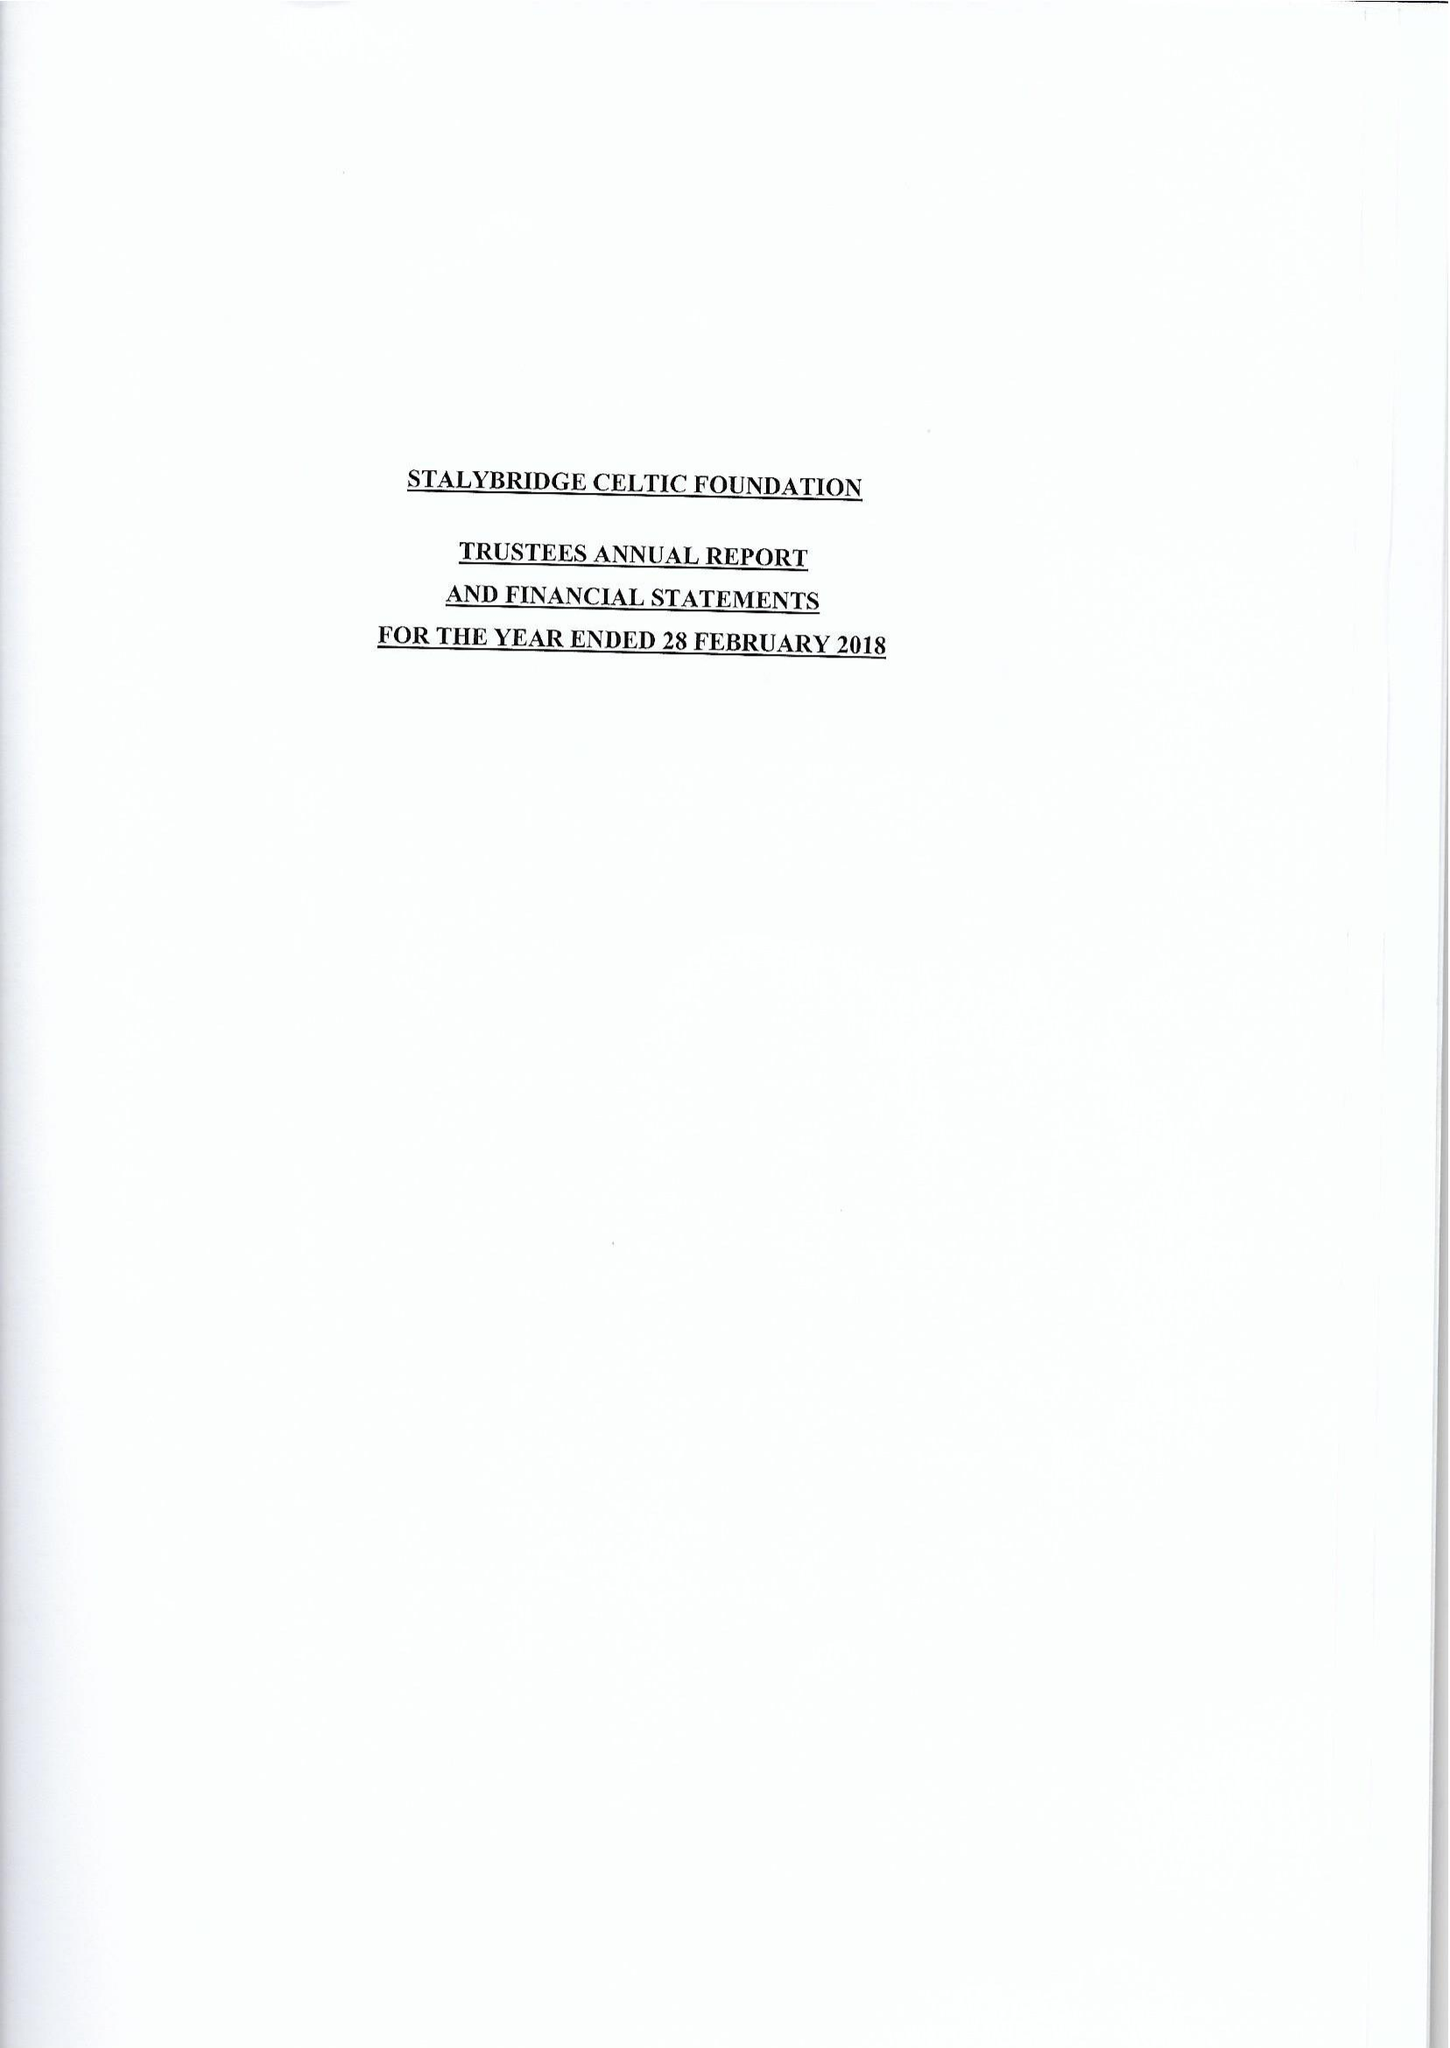What is the value for the charity_number?
Answer the question using a single word or phrase. 1173057 